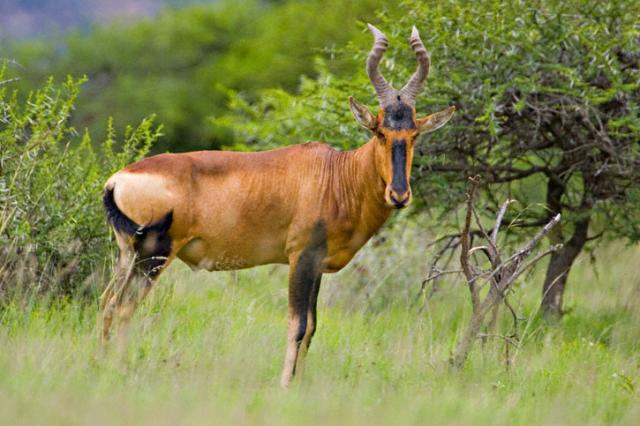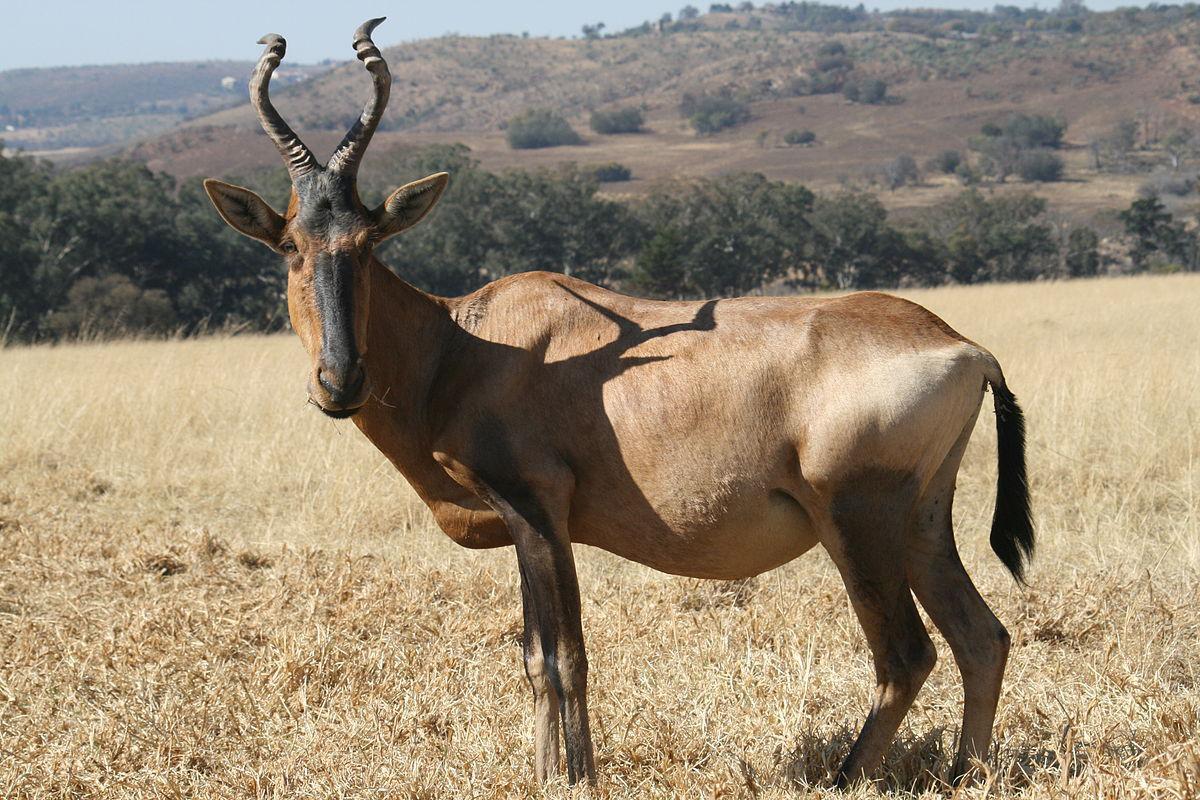The first image is the image on the left, the second image is the image on the right. Evaluate the accuracy of this statement regarding the images: "At least one image includes a young animal and an adult with horns.". Is it true? Answer yes or no. No. 